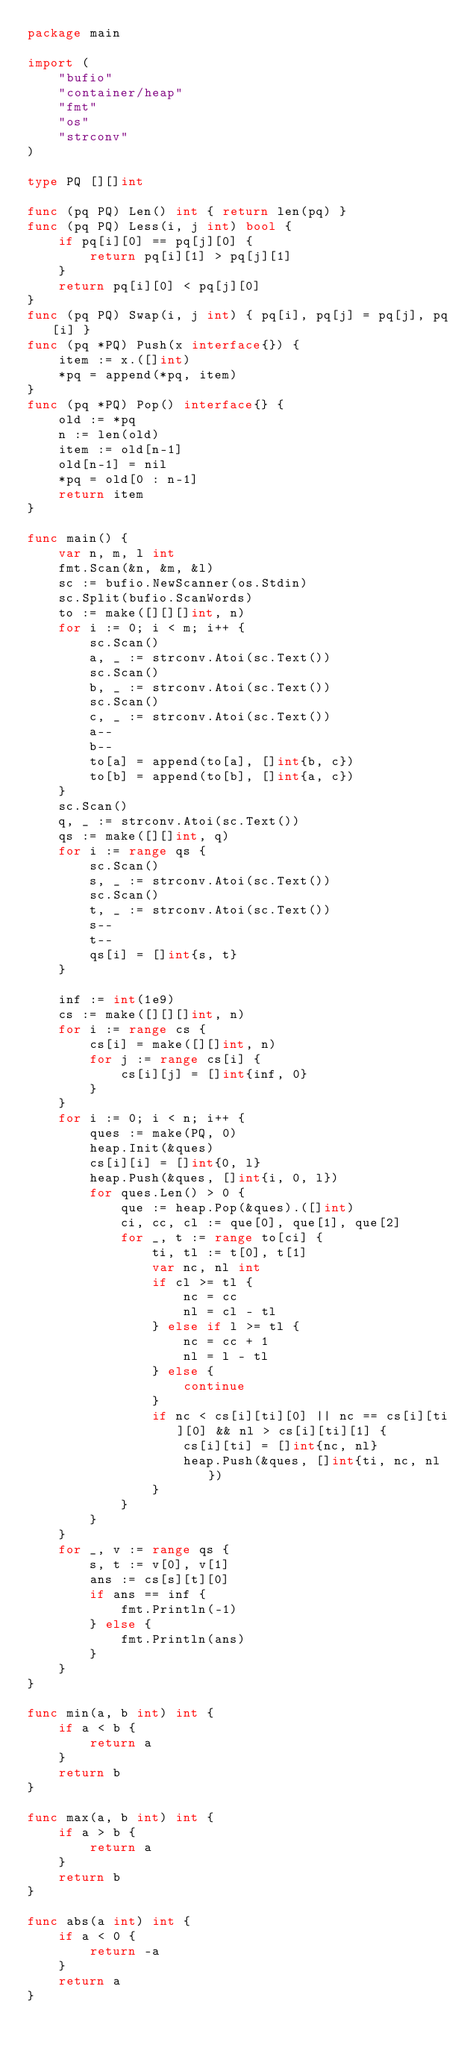Convert code to text. <code><loc_0><loc_0><loc_500><loc_500><_Go_>package main

import (
	"bufio"
	"container/heap"
	"fmt"
	"os"
	"strconv"
)

type PQ [][]int

func (pq PQ) Len() int { return len(pq) }
func (pq PQ) Less(i, j int) bool {
	if pq[i][0] == pq[j][0] {
		return pq[i][1] > pq[j][1]
	}
	return pq[i][0] < pq[j][0]
}
func (pq PQ) Swap(i, j int) { pq[i], pq[j] = pq[j], pq[i] }
func (pq *PQ) Push(x interface{}) {
	item := x.([]int)
	*pq = append(*pq, item)
}
func (pq *PQ) Pop() interface{} {
	old := *pq
	n := len(old)
	item := old[n-1]
	old[n-1] = nil
	*pq = old[0 : n-1]
	return item
}

func main() {
	var n, m, l int
	fmt.Scan(&n, &m, &l)
	sc := bufio.NewScanner(os.Stdin)
	sc.Split(bufio.ScanWords)
	to := make([][][]int, n)
	for i := 0; i < m; i++ {
		sc.Scan()
		a, _ := strconv.Atoi(sc.Text())
		sc.Scan()
		b, _ := strconv.Atoi(sc.Text())
		sc.Scan()
		c, _ := strconv.Atoi(sc.Text())
		a--
		b--
		to[a] = append(to[a], []int{b, c})
		to[b] = append(to[b], []int{a, c})
	}
	sc.Scan()
	q, _ := strconv.Atoi(sc.Text())
	qs := make([][]int, q)
	for i := range qs {
		sc.Scan()
		s, _ := strconv.Atoi(sc.Text())
		sc.Scan()
		t, _ := strconv.Atoi(sc.Text())
		s--
		t--
		qs[i] = []int{s, t}
	}

	inf := int(1e9)
	cs := make([][][]int, n)
	for i := range cs {
		cs[i] = make([][]int, n)
		for j := range cs[i] {
			cs[i][j] = []int{inf, 0}
		}
	}
	for i := 0; i < n; i++ {
		ques := make(PQ, 0)
		heap.Init(&ques)
		cs[i][i] = []int{0, l}
		heap.Push(&ques, []int{i, 0, l})
		for ques.Len() > 0 {
			que := heap.Pop(&ques).([]int)
			ci, cc, cl := que[0], que[1], que[2]
			for _, t := range to[ci] {
				ti, tl := t[0], t[1]
				var nc, nl int
				if cl >= tl {
					nc = cc
					nl = cl - tl
				} else if l >= tl {
					nc = cc + 1
					nl = l - tl
				} else {
					continue
				}
				if nc < cs[i][ti][0] || nc == cs[i][ti][0] && nl > cs[i][ti][1] {
					cs[i][ti] = []int{nc, nl}
					heap.Push(&ques, []int{ti, nc, nl})
				}
			}
		}
	}
	for _, v := range qs {
		s, t := v[0], v[1]
		ans := cs[s][t][0]
		if ans == inf {
			fmt.Println(-1)
		} else {
			fmt.Println(ans)
		}
	}
}

func min(a, b int) int {
	if a < b {
		return a
	}
	return b
}

func max(a, b int) int {
	if a > b {
		return a
	}
	return b
}

func abs(a int) int {
	if a < 0 {
		return -a
	}
	return a
}
</code> 